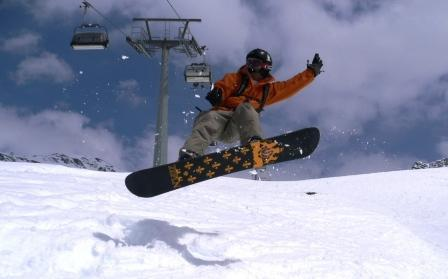What use would sitting in the seats have? transportation 